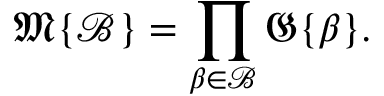<formula> <loc_0><loc_0><loc_500><loc_500>{ \mathfrak { M } } \{ { \mathcal { B } } \} = \prod _ { \beta \in { \mathcal { B } } } { \mathfrak { G } } \{ \beta \} .</formula> 